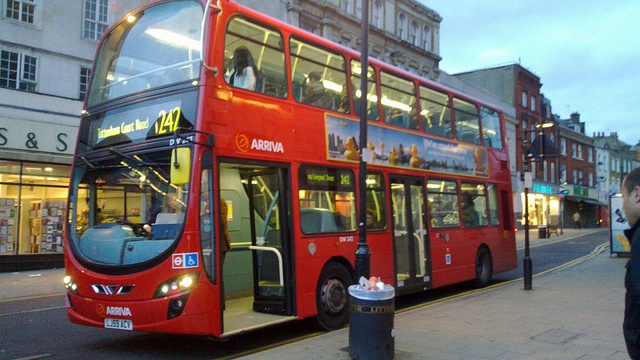Describe the objects in this image and their specific colors. I can see bus in gray, black, brown, and maroon tones, people in gray, black, and navy tones, people in gray, black, darkgray, and olive tones, people in gray, olive, and darkgreen tones, and people in gray, black, olive, and maroon tones in this image. 